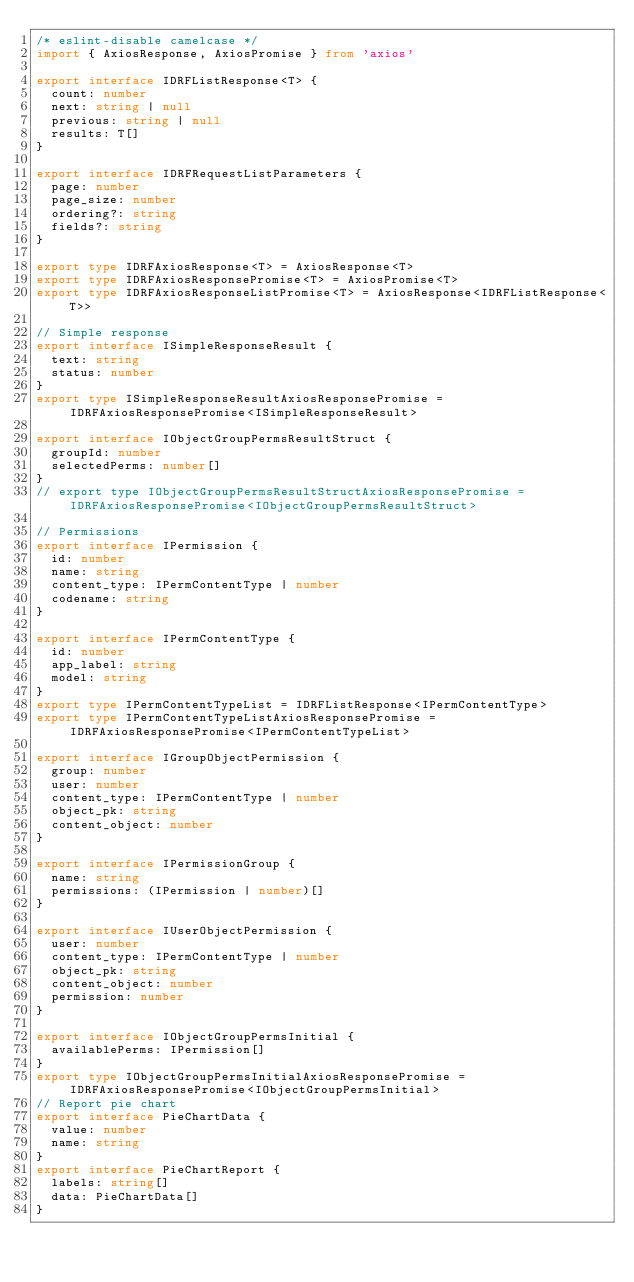Convert code to text. <code><loc_0><loc_0><loc_500><loc_500><_TypeScript_>/* eslint-disable camelcase */
import { AxiosResponse, AxiosPromise } from 'axios'

export interface IDRFListResponse<T> {
  count: number
  next: string | null
  previous: string | null
  results: T[]
}

export interface IDRFRequestListParameters {
  page: number
  page_size: number
  ordering?: string
  fields?: string
}

export type IDRFAxiosResponse<T> = AxiosResponse<T>
export type IDRFAxiosResponsePromise<T> = AxiosPromise<T>
export type IDRFAxiosResponseListPromise<T> = AxiosResponse<IDRFListResponse<T>>

// Simple response
export interface ISimpleResponseResult {
  text: string
  status: number
}
export type ISimpleResponseResultAxiosResponsePromise = IDRFAxiosResponsePromise<ISimpleResponseResult>

export interface IObjectGroupPermsResultStruct {
  groupId: number
  selectedPerms: number[]
}
// export type IObjectGroupPermsResultStructAxiosResponsePromise = IDRFAxiosResponsePromise<IObjectGroupPermsResultStruct>

// Permissions
export interface IPermission {
  id: number
  name: string
  content_type: IPermContentType | number
  codename: string
}

export interface IPermContentType {
  id: number
  app_label: string
  model: string
}
export type IPermContentTypeList = IDRFListResponse<IPermContentType>
export type IPermContentTypeListAxiosResponsePromise = IDRFAxiosResponsePromise<IPermContentTypeList>

export interface IGroupObjectPermission {
  group: number
  user: number
  content_type: IPermContentType | number
  object_pk: string
  content_object: number
}

export interface IPermissionGroup {
  name: string
  permissions: (IPermission | number)[]
}

export interface IUserObjectPermission {
  user: number
  content_type: IPermContentType | number
  object_pk: string
  content_object: number
  permission: number
}

export interface IObjectGroupPermsInitial {
  availablePerms: IPermission[]
}
export type IObjectGroupPermsInitialAxiosResponsePromise = IDRFAxiosResponsePromise<IObjectGroupPermsInitial>
// Report pie chart
export interface PieChartData {
  value: number
  name: string
}
export interface PieChartReport {
  labels: string[]
  data: PieChartData[]
}
</code> 